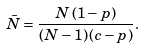Convert formula to latex. <formula><loc_0><loc_0><loc_500><loc_500>\bar { N } = \frac { N \, ( 1 - p ) } { ( N - 1 ) \, ( c - p ) } .</formula> 